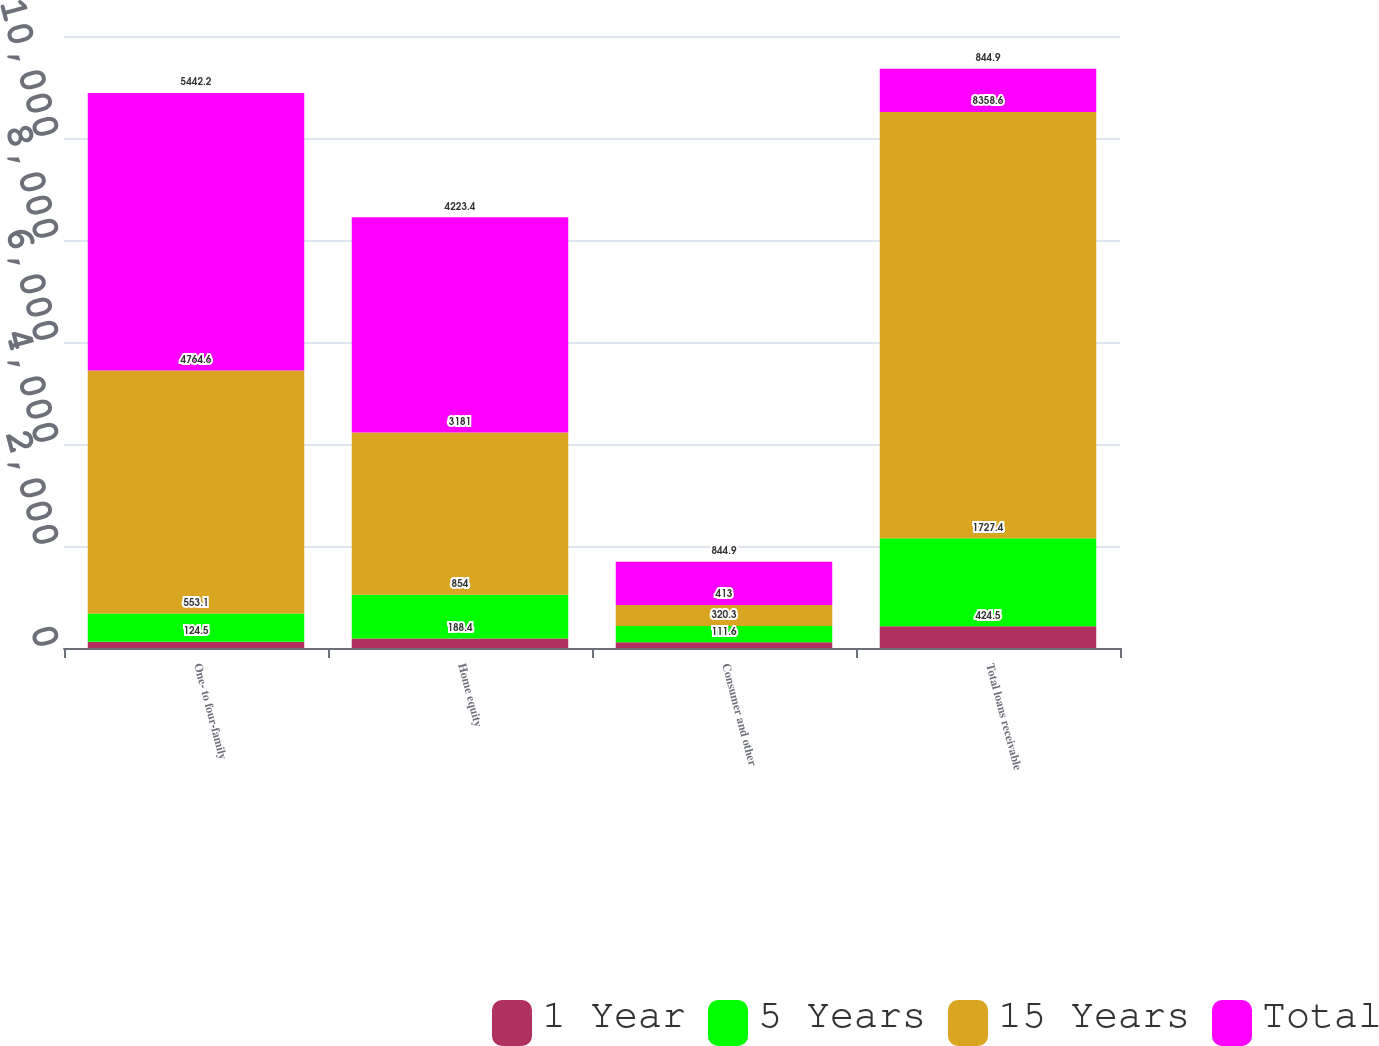Convert chart. <chart><loc_0><loc_0><loc_500><loc_500><stacked_bar_chart><ecel><fcel>One- to four-family<fcel>Home equity<fcel>Consumer and other<fcel>Total loans receivable<nl><fcel>1 Year<fcel>124.5<fcel>188.4<fcel>111.6<fcel>424.5<nl><fcel>5 Years<fcel>553.1<fcel>854<fcel>320.3<fcel>1727.4<nl><fcel>15 Years<fcel>4764.6<fcel>3181<fcel>413<fcel>8358.6<nl><fcel>Total<fcel>5442.2<fcel>4223.4<fcel>844.9<fcel>844.9<nl></chart> 